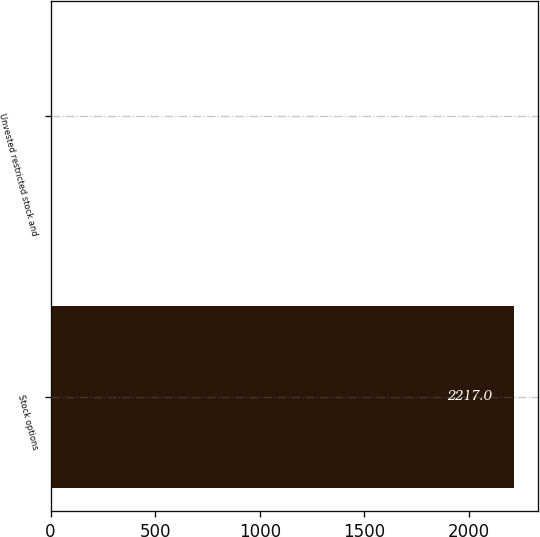<chart> <loc_0><loc_0><loc_500><loc_500><bar_chart><fcel>Stock options<fcel>Unvested restricted stock and<nl><fcel>2217<fcel>5<nl></chart> 